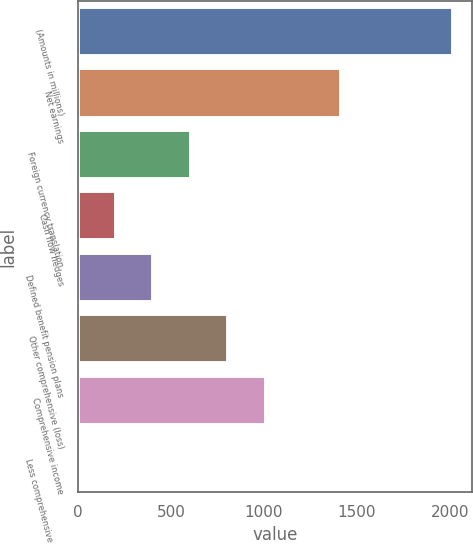Convert chart. <chart><loc_0><loc_0><loc_500><loc_500><bar_chart><fcel>(Amounts in millions)<fcel>Net earnings<fcel>Foreign currency translation<fcel>Cash flow hedges<fcel>Defined benefit pension plans<fcel>Other comprehensive (loss)<fcel>Comprehensive income<fcel>Less comprehensive (income)<nl><fcel>2018<fcel>1412.66<fcel>605.54<fcel>201.98<fcel>403.76<fcel>807.32<fcel>1009.1<fcel>0.2<nl></chart> 